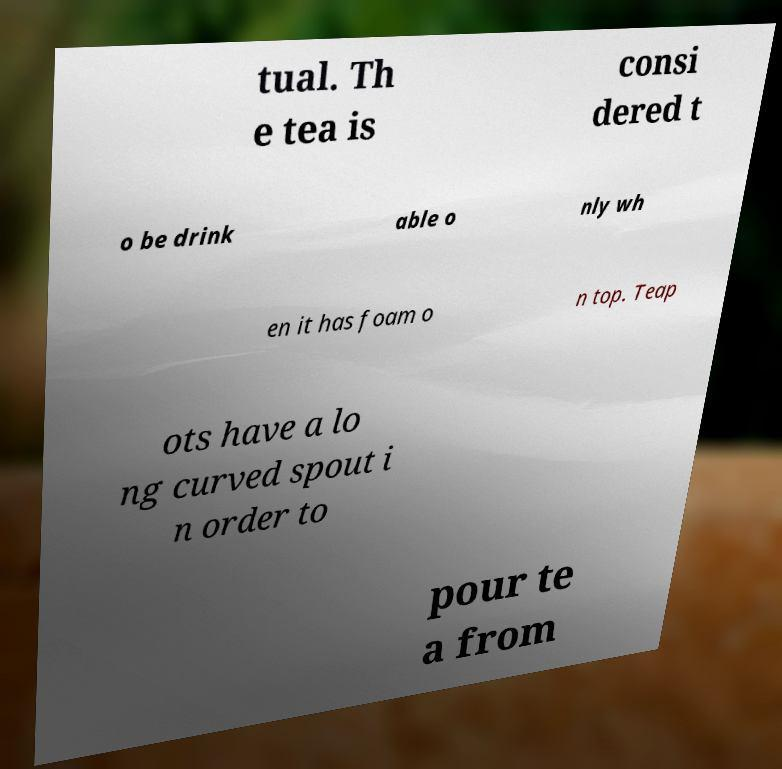Please identify and transcribe the text found in this image. tual. Th e tea is consi dered t o be drink able o nly wh en it has foam o n top. Teap ots have a lo ng curved spout i n order to pour te a from 